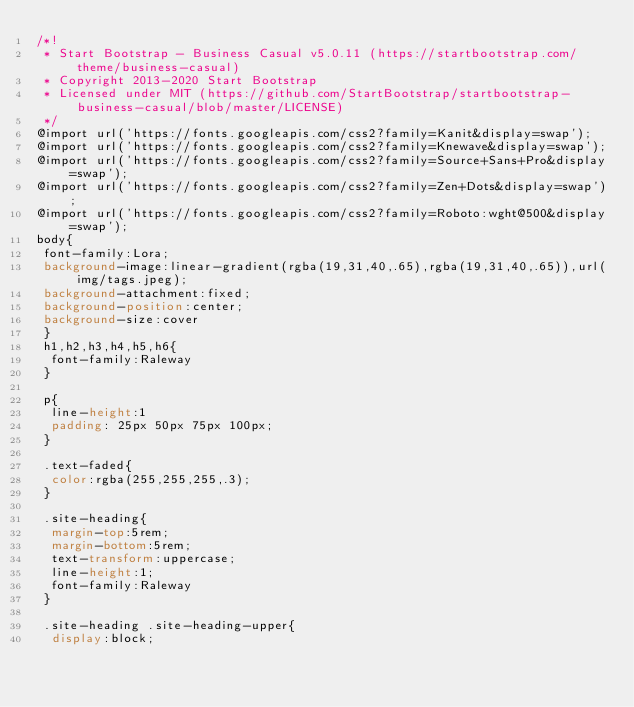<code> <loc_0><loc_0><loc_500><loc_500><_CSS_>/*!
 * Start Bootstrap - Business Casual v5.0.11 (https://startbootstrap.com/theme/business-casual)
 * Copyright 2013-2020 Start Bootstrap
 * Licensed under MIT (https://github.com/StartBootstrap/startbootstrap-business-casual/blob/master/LICENSE)
 */
@import url('https://fonts.googleapis.com/css2?family=Kanit&display=swap');
@import url('https://fonts.googleapis.com/css2?family=Knewave&display=swap');
@import url('https://fonts.googleapis.com/css2?family=Source+Sans+Pro&display=swap');
@import url('https://fonts.googleapis.com/css2?family=Zen+Dots&display=swap');
@import url('https://fonts.googleapis.com/css2?family=Roboto:wght@500&display=swap');
body{
 font-family:Lora;
 background-image:linear-gradient(rgba(19,31,40,.65),rgba(19,31,40,.65)),url(img/tags.jpeg);
 background-attachment:fixed;
 background-position:center;
 background-size:cover
 }
 h1,h2,h3,h4,h5,h6{
 	font-family:Raleway
 }

 p{
 	line-height:1
 	padding: 25px 50px 75px 100px;
 }

 .text-faded{
 	color:rgba(255,255,255,.3);
 }

 .site-heading{
 	margin-top:5rem;
 	margin-bottom:5rem;
 	text-transform:uppercase;
 	line-height:1;
 	font-family:Raleway
 }

 .site-heading .site-heading-upper{
 	display:block;</code> 